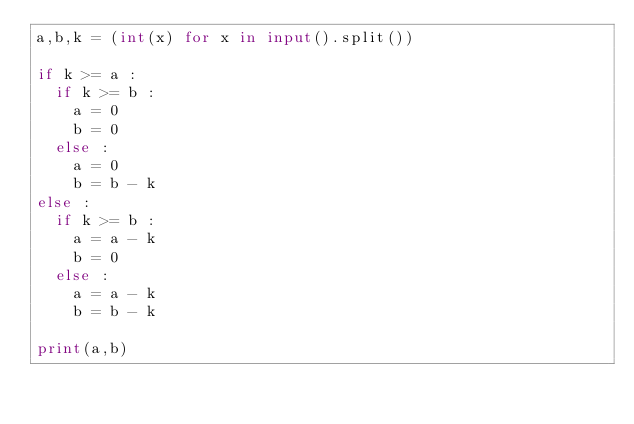Convert code to text. <code><loc_0><loc_0><loc_500><loc_500><_Python_>a,b,k = (int(x) for x in input().split())

if k >= a :
  if k >= b :
    a = 0
    b = 0
  else :
    a = 0
    b = b - k
else :
  if k >= b :
    a = a - k
    b = 0
  else :
    a = a - k
    b = b - k
    
print(a,b)</code> 